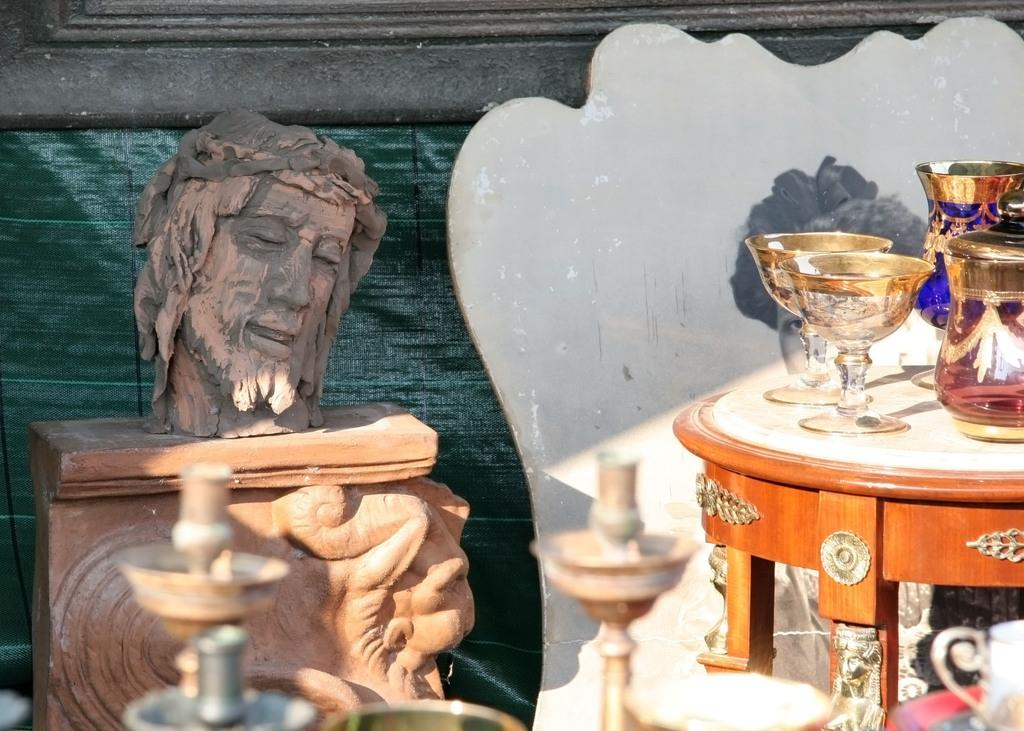What is the main subject in the image? There is a sculpture in the image. What other objects are visible in the image? There are glasses and jugs visible in the image. Where are all the mentioned objects located? All the mentioned objects are on a table. What type of guide is present in the image? There is no guide present in the image; it features a sculpture, glasses, and jugs on a table. What is the mist like in the image? There is no mist present in the image; it is a still image featuring a sculpture, glasses, and jugs on a table. 